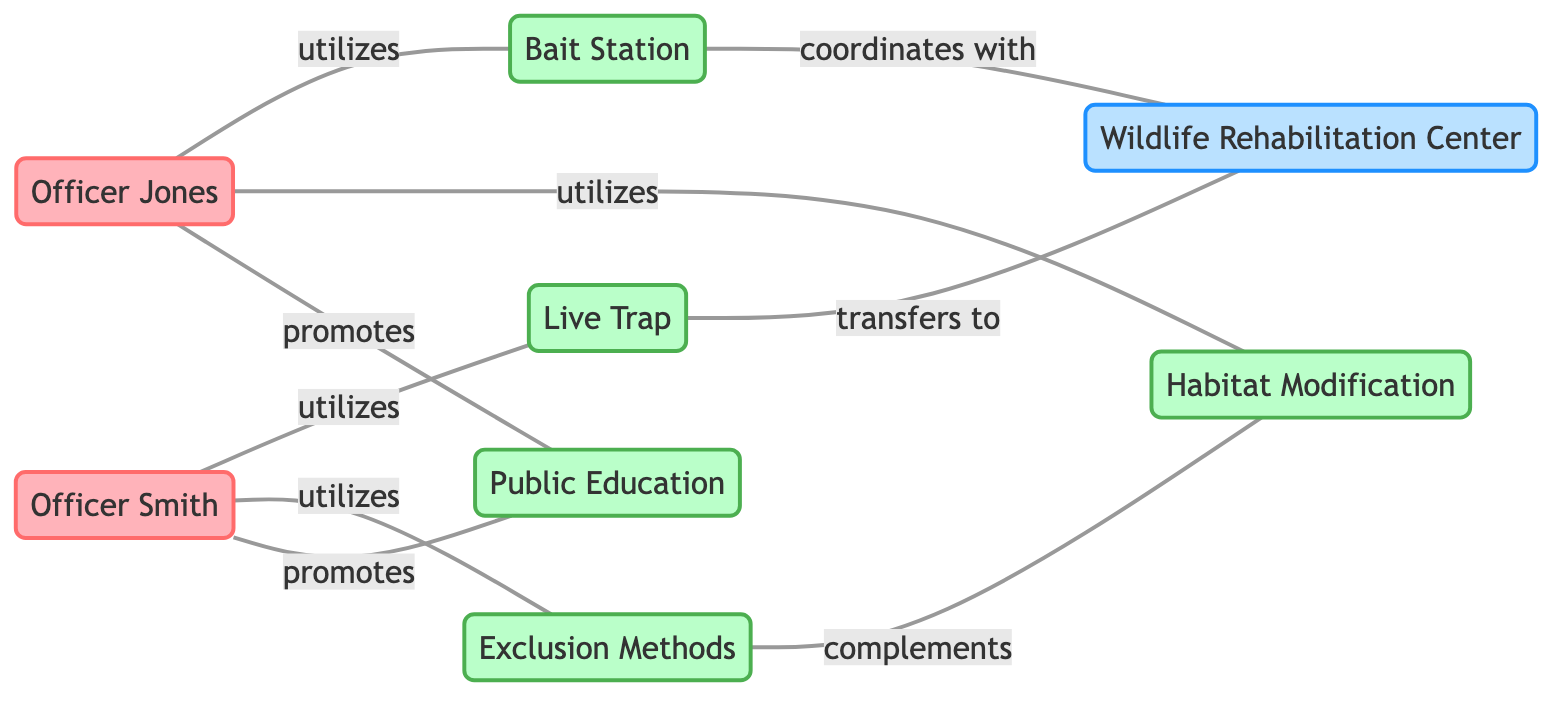What is the total number of officers represented in the diagram? The diagram includes two nodes representing officers: Officer Smith and Officer Jones. Hence, counting these gives a total of 2 officers.
Answer: 2 Which method does Officer Smith utilize? The diagram shows an edge from Officer Smith to the Live Trap, indicating that he utilizes this method. Hence, the answer is Live Trap.
Answer: Live Trap How many different methods of raccoon control are utilized by the officers in the diagram? The diagram lists five methods (Live Trap, Bait Station, Exclusion Methods, Habitat Modification, Public Education). Therefore, the total number of methods utilized is 5.
Answer: 5 Which method is complemented by Exclusion Methods? The edge connects Exclusion Methods to Habitat Modification, indicating that Exclusion Methods complement Habitat Modification. Thus, the answer is Habitat Modification.
Answer: Habitat Modification How many times is Public Education promoted by the officers? Both Officer Smith and Officer Jones promote Public Education, resulting in a total of 2 promotions.
Answer: 2 Which officer utilizes Bait Station? The direct connection in the diagram shows that Officer Jones utilizes Bait Station. Thus, the answer is Officer Jones.
Answer: Officer Jones What facility does Live Trap transfer to? The edge in the diagram shows that Live Trap transfers to Wildlife Rehabilitation Center, making that the answer.
Answer: Wildlife Rehabilitation Center Which method coordinates with Wildlife Rehabilitation Center? The diagram indicates that Bait Station coordinates with Wildlife Rehabilitation Center, so the answer is Bait Station.
Answer: Bait Station Which officer promotes the most methods? Both Officer Smith and Officer Jones promote Public Education, but Officer Smith also utilizes two methods (Live Trap and Exclusion Methods) compared to Officer Jones who utilizes two methods (Bait Station and Habitat Modification). Since they have the same promotions, the answer would still consider their other utilizes; thus, Officer Smith is the one.
Answer: Officer Smith 